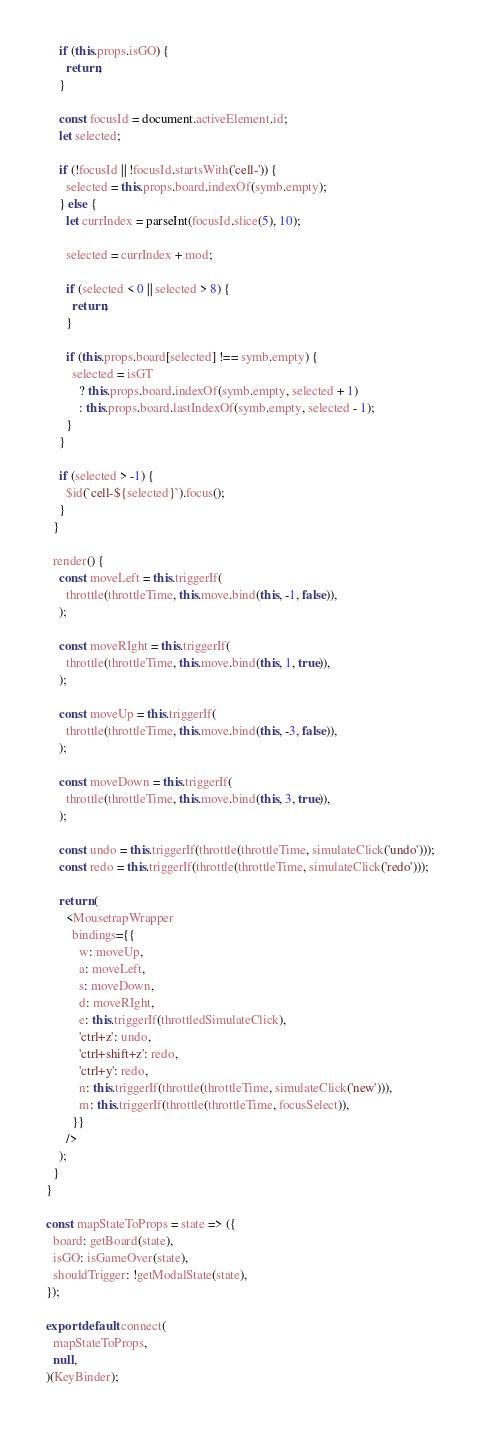Convert code to text. <code><loc_0><loc_0><loc_500><loc_500><_JavaScript_>    if (this.props.isGO) {
      return;
    }

    const focusId = document.activeElement.id;
    let selected;

    if (!focusId || !focusId.startsWith('cell-')) {
      selected = this.props.board.indexOf(symb.empty);
    } else {
      let currIndex = parseInt(focusId.slice(5), 10);

      selected = currIndex + mod;

      if (selected < 0 || selected > 8) {
        return;
      }

      if (this.props.board[selected] !== symb.empty) {
        selected = isGT
          ? this.props.board.indexOf(symb.empty, selected + 1)
          : this.props.board.lastIndexOf(symb.empty, selected - 1);
      }
    }

    if (selected > -1) {
      $id(`cell-${selected}`).focus();
    }
  }

  render() {
    const moveLeft = this.triggerIf(
      throttle(throttleTime, this.move.bind(this, -1, false)),
    );

    const moveRIght = this.triggerIf(
      throttle(throttleTime, this.move.bind(this, 1, true)),
    );

    const moveUp = this.triggerIf(
      throttle(throttleTime, this.move.bind(this, -3, false)),
    );

    const moveDown = this.triggerIf(
      throttle(throttleTime, this.move.bind(this, 3, true)),
    );

    const undo = this.triggerIf(throttle(throttleTime, simulateClick('undo')));
    const redo = this.triggerIf(throttle(throttleTime, simulateClick('redo')));

    return (
      <MousetrapWrapper
        bindings={{
          w: moveUp,
          a: moveLeft,
          s: moveDown,
          d: moveRIght,
          e: this.triggerIf(throttledSimulateClick),
          'ctrl+z': undo,
          'ctrl+shift+z': redo,
          'ctrl+y': redo,
          n: this.triggerIf(throttle(throttleTime, simulateClick('new'))),
          m: this.triggerIf(throttle(throttleTime, focusSelect)),
        }}
      />
    );
  }
}

const mapStateToProps = state => ({
  board: getBoard(state),
  isGO: isGameOver(state),
  shouldTrigger: !getModalState(state),
});

export default connect(
  mapStateToProps,
  null,
)(KeyBinder);
</code> 